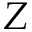Convert formula to latex. <formula><loc_0><loc_0><loc_500><loc_500>Z</formula> 